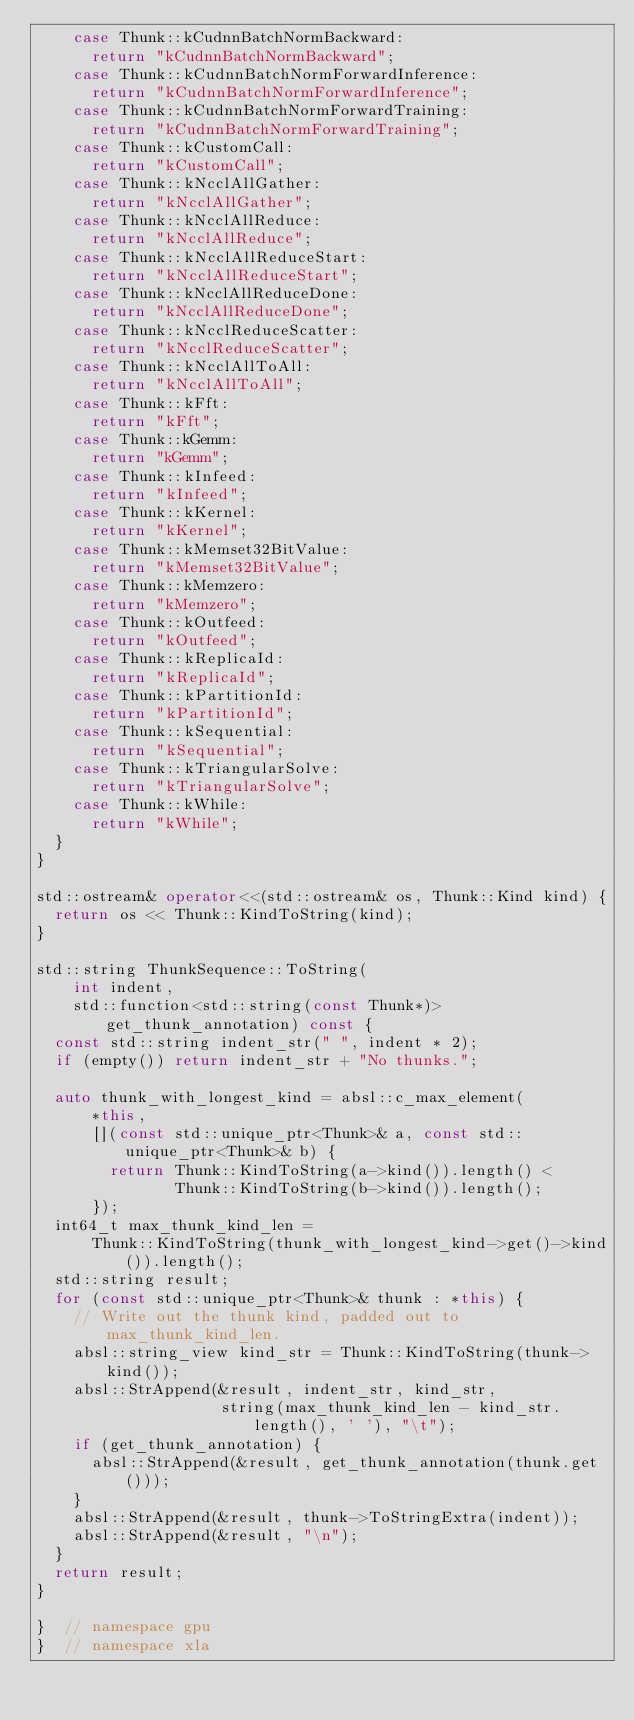Convert code to text. <code><loc_0><loc_0><loc_500><loc_500><_C++_>    case Thunk::kCudnnBatchNormBackward:
      return "kCudnnBatchNormBackward";
    case Thunk::kCudnnBatchNormForwardInference:
      return "kCudnnBatchNormForwardInference";
    case Thunk::kCudnnBatchNormForwardTraining:
      return "kCudnnBatchNormForwardTraining";
    case Thunk::kCustomCall:
      return "kCustomCall";
    case Thunk::kNcclAllGather:
      return "kNcclAllGather";
    case Thunk::kNcclAllReduce:
      return "kNcclAllReduce";
    case Thunk::kNcclAllReduceStart:
      return "kNcclAllReduceStart";
    case Thunk::kNcclAllReduceDone:
      return "kNcclAllReduceDone";
    case Thunk::kNcclReduceScatter:
      return "kNcclReduceScatter";
    case Thunk::kNcclAllToAll:
      return "kNcclAllToAll";
    case Thunk::kFft:
      return "kFft";
    case Thunk::kGemm:
      return "kGemm";
    case Thunk::kInfeed:
      return "kInfeed";
    case Thunk::kKernel:
      return "kKernel";
    case Thunk::kMemset32BitValue:
      return "kMemset32BitValue";
    case Thunk::kMemzero:
      return "kMemzero";
    case Thunk::kOutfeed:
      return "kOutfeed";
    case Thunk::kReplicaId:
      return "kReplicaId";
    case Thunk::kPartitionId:
      return "kPartitionId";
    case Thunk::kSequential:
      return "kSequential";
    case Thunk::kTriangularSolve:
      return "kTriangularSolve";
    case Thunk::kWhile:
      return "kWhile";
  }
}

std::ostream& operator<<(std::ostream& os, Thunk::Kind kind) {
  return os << Thunk::KindToString(kind);
}

std::string ThunkSequence::ToString(
    int indent,
    std::function<std::string(const Thunk*)> get_thunk_annotation) const {
  const std::string indent_str(" ", indent * 2);
  if (empty()) return indent_str + "No thunks.";

  auto thunk_with_longest_kind = absl::c_max_element(
      *this,
      [](const std::unique_ptr<Thunk>& a, const std::unique_ptr<Thunk>& b) {
        return Thunk::KindToString(a->kind()).length() <
               Thunk::KindToString(b->kind()).length();
      });
  int64_t max_thunk_kind_len =
      Thunk::KindToString(thunk_with_longest_kind->get()->kind()).length();
  std::string result;
  for (const std::unique_ptr<Thunk>& thunk : *this) {
    // Write out the thunk kind, padded out to max_thunk_kind_len.
    absl::string_view kind_str = Thunk::KindToString(thunk->kind());
    absl::StrAppend(&result, indent_str, kind_str,
                    string(max_thunk_kind_len - kind_str.length(), ' '), "\t");
    if (get_thunk_annotation) {
      absl::StrAppend(&result, get_thunk_annotation(thunk.get()));
    }
    absl::StrAppend(&result, thunk->ToStringExtra(indent));
    absl::StrAppend(&result, "\n");
  }
  return result;
}

}  // namespace gpu
}  // namespace xla
</code> 